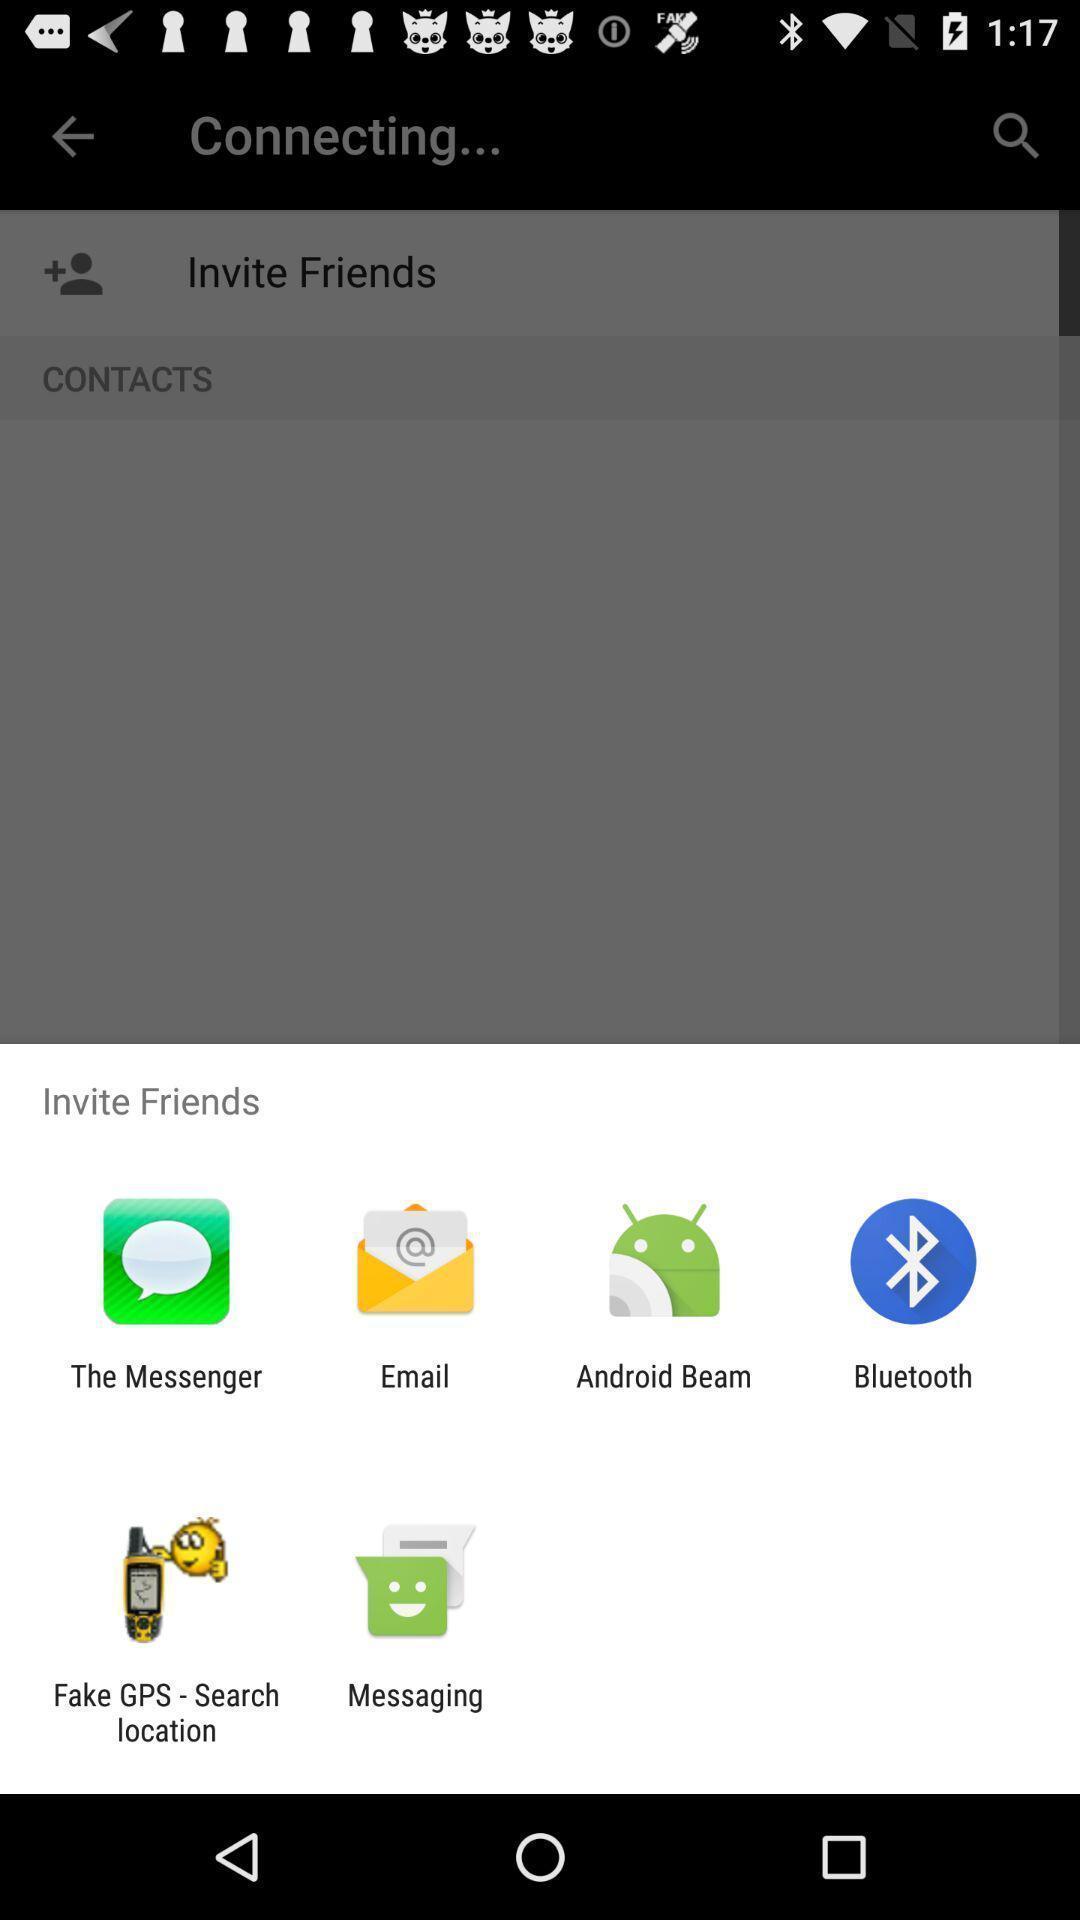Tell me what you see in this picture. Pop-up displaying various inviting options. 